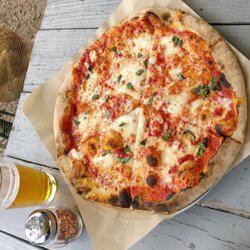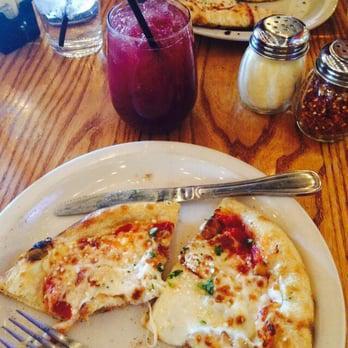The first image is the image on the left, the second image is the image on the right. Considering the images on both sides, is "The left image shows a pizza that is sliced but no slices are missing, and the right image shows a plate with some slices on it." valid? Answer yes or no. Yes. The first image is the image on the left, the second image is the image on the right. Evaluate the accuracy of this statement regarding the images: "At least one straw is visible in the right image.". Is it true? Answer yes or no. Yes. 